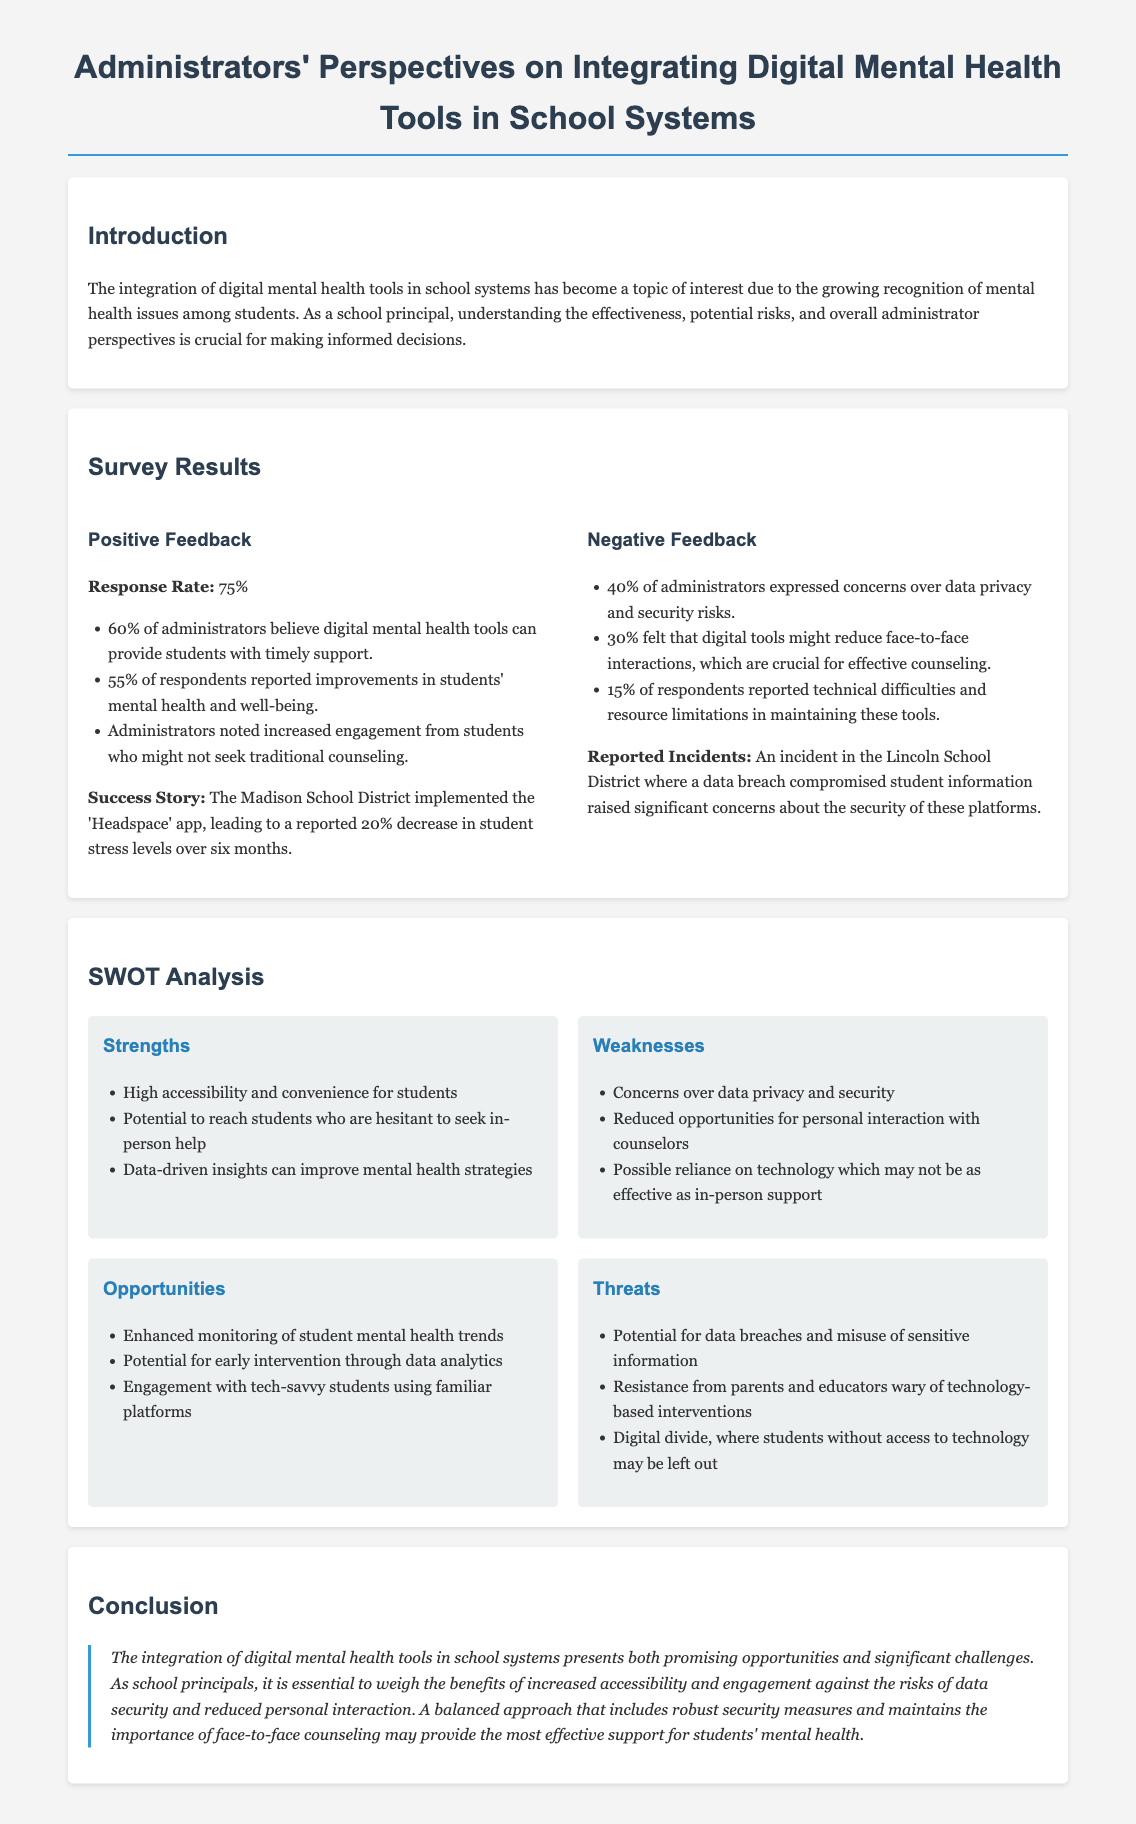What was the response rate of the survey? The response rate indicates the percentage of administrators that participated in the survey, which is 75%.
Answer: 75% What percentage of administrators believe digital tools can provide timely support? This percentage shows how many administrators recognize the potential effectiveness of digital tools, which is 60%.
Answer: 60% What is one success story mentioned in the document? The document highlights a specific case in the Madison School District where a particular app led to positive outcomes, indicating a 20% decrease in student stress levels.
Answer: 20% decrease in student stress levels What were the major concerns regarding digital mental health tools? The document lists several issues raised by administrators, identifying data privacy and security as the primary concern, which is 40%.
Answer: Data privacy and security What is one opportunity mentioned in the SWOT analysis? The SWOT analysis presents potential positive developments in the context of digital mental health tools, including enhanced monitoring of student mental health trends.
Answer: Enhanced monitoring of student mental health trends What incident raised significant concerns about digital tools? The document refers to a particular occurrence in the Lincoln School District that highlighted risks associated with digital platforms, specifically a data breach.
Answer: Data breach What is one threat mentioned in the SWOT analysis? The SWOT analysis highlights risks associated with using digital platforms, notably the potential for data breaches and misuse of sensitive information.
Answer: Data breaches What is a strength of digital mental health tools? The document points out several advantages of these tools, indicating high accessibility and convenience for students as a significant strength.
Answer: High accessibility and convenience for students 